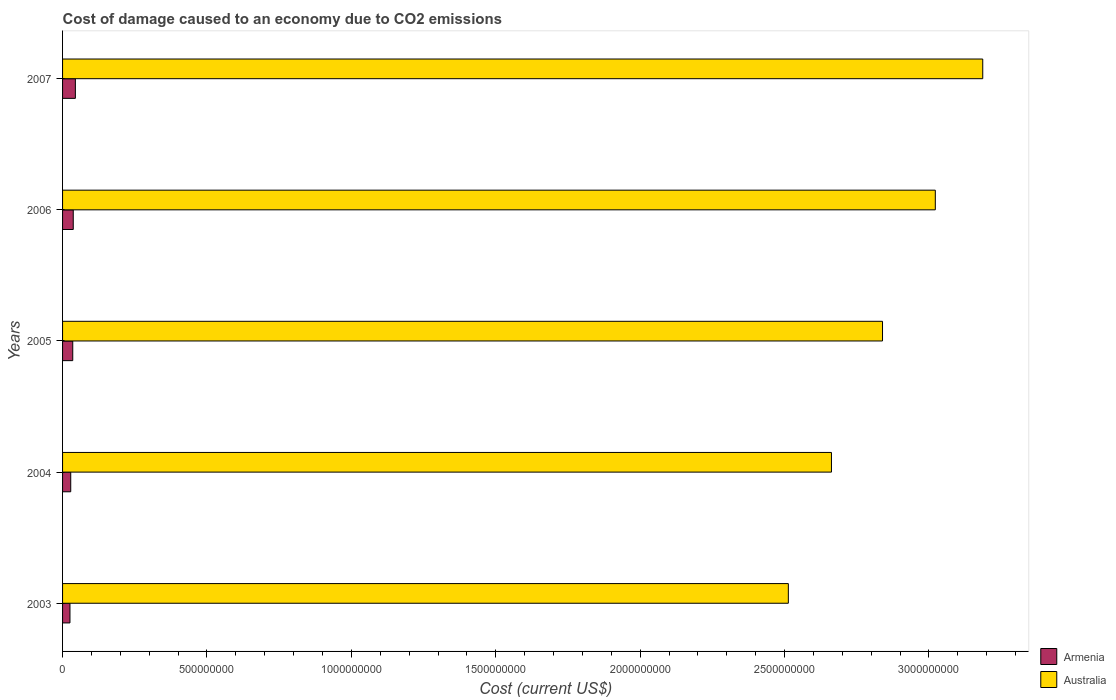Are the number of bars per tick equal to the number of legend labels?
Provide a succinct answer. Yes. Are the number of bars on each tick of the Y-axis equal?
Your response must be concise. Yes. How many bars are there on the 1st tick from the bottom?
Offer a terse response. 2. What is the cost of damage caused due to CO2 emissisons in Australia in 2007?
Offer a terse response. 3.19e+09. Across all years, what is the maximum cost of damage caused due to CO2 emissisons in Australia?
Provide a short and direct response. 3.19e+09. Across all years, what is the minimum cost of damage caused due to CO2 emissisons in Australia?
Give a very brief answer. 2.51e+09. In which year was the cost of damage caused due to CO2 emissisons in Australia maximum?
Offer a terse response. 2007. In which year was the cost of damage caused due to CO2 emissisons in Armenia minimum?
Your answer should be compact. 2003. What is the total cost of damage caused due to CO2 emissisons in Armenia in the graph?
Offer a very short reply. 1.71e+08. What is the difference between the cost of damage caused due to CO2 emissisons in Armenia in 2005 and that in 2006?
Provide a short and direct response. -1.71e+06. What is the difference between the cost of damage caused due to CO2 emissisons in Australia in 2006 and the cost of damage caused due to CO2 emissisons in Armenia in 2003?
Your answer should be very brief. 3.00e+09. What is the average cost of damage caused due to CO2 emissisons in Australia per year?
Offer a very short reply. 2.84e+09. In the year 2006, what is the difference between the cost of damage caused due to CO2 emissisons in Armenia and cost of damage caused due to CO2 emissisons in Australia?
Provide a succinct answer. -2.98e+09. What is the ratio of the cost of damage caused due to CO2 emissisons in Armenia in 2006 to that in 2007?
Provide a short and direct response. 0.83. Is the cost of damage caused due to CO2 emissisons in Australia in 2003 less than that in 2004?
Your response must be concise. Yes. Is the difference between the cost of damage caused due to CO2 emissisons in Armenia in 2003 and 2004 greater than the difference between the cost of damage caused due to CO2 emissisons in Australia in 2003 and 2004?
Provide a succinct answer. Yes. What is the difference between the highest and the second highest cost of damage caused due to CO2 emissisons in Australia?
Give a very brief answer. 1.64e+08. What is the difference between the highest and the lowest cost of damage caused due to CO2 emissisons in Australia?
Give a very brief answer. 6.73e+08. What does the 2nd bar from the top in 2006 represents?
Your response must be concise. Armenia. What does the 2nd bar from the bottom in 2004 represents?
Ensure brevity in your answer.  Australia. What is the difference between two consecutive major ticks on the X-axis?
Make the answer very short. 5.00e+08. Are the values on the major ticks of X-axis written in scientific E-notation?
Give a very brief answer. No. Does the graph contain any zero values?
Offer a terse response. No. Where does the legend appear in the graph?
Give a very brief answer. Bottom right. How many legend labels are there?
Offer a very short reply. 2. What is the title of the graph?
Give a very brief answer. Cost of damage caused to an economy due to CO2 emissions. What is the label or title of the X-axis?
Your response must be concise. Cost (current US$). What is the Cost (current US$) of Armenia in 2003?
Offer a terse response. 2.56e+07. What is the Cost (current US$) in Australia in 2003?
Make the answer very short. 2.51e+09. What is the Cost (current US$) of Armenia in 2004?
Your answer should be very brief. 2.83e+07. What is the Cost (current US$) of Australia in 2004?
Provide a succinct answer. 2.66e+09. What is the Cost (current US$) of Armenia in 2005?
Offer a very short reply. 3.53e+07. What is the Cost (current US$) in Australia in 2005?
Offer a very short reply. 2.84e+09. What is the Cost (current US$) in Armenia in 2006?
Give a very brief answer. 3.70e+07. What is the Cost (current US$) of Australia in 2006?
Your answer should be compact. 3.02e+09. What is the Cost (current US$) in Armenia in 2007?
Provide a short and direct response. 4.44e+07. What is the Cost (current US$) in Australia in 2007?
Your response must be concise. 3.19e+09. Across all years, what is the maximum Cost (current US$) in Armenia?
Provide a short and direct response. 4.44e+07. Across all years, what is the maximum Cost (current US$) in Australia?
Offer a terse response. 3.19e+09. Across all years, what is the minimum Cost (current US$) of Armenia?
Keep it short and to the point. 2.56e+07. Across all years, what is the minimum Cost (current US$) in Australia?
Your answer should be very brief. 2.51e+09. What is the total Cost (current US$) of Armenia in the graph?
Keep it short and to the point. 1.71e+08. What is the total Cost (current US$) of Australia in the graph?
Make the answer very short. 1.42e+1. What is the difference between the Cost (current US$) in Armenia in 2003 and that in 2004?
Offer a terse response. -2.69e+06. What is the difference between the Cost (current US$) of Australia in 2003 and that in 2004?
Give a very brief answer. -1.49e+08. What is the difference between the Cost (current US$) in Armenia in 2003 and that in 2005?
Provide a succinct answer. -9.66e+06. What is the difference between the Cost (current US$) in Australia in 2003 and that in 2005?
Your answer should be compact. -3.26e+08. What is the difference between the Cost (current US$) in Armenia in 2003 and that in 2006?
Your answer should be compact. -1.14e+07. What is the difference between the Cost (current US$) in Australia in 2003 and that in 2006?
Provide a succinct answer. -5.09e+08. What is the difference between the Cost (current US$) of Armenia in 2003 and that in 2007?
Your response must be concise. -1.87e+07. What is the difference between the Cost (current US$) of Australia in 2003 and that in 2007?
Your answer should be compact. -6.73e+08. What is the difference between the Cost (current US$) in Armenia in 2004 and that in 2005?
Offer a terse response. -6.97e+06. What is the difference between the Cost (current US$) in Australia in 2004 and that in 2005?
Provide a succinct answer. -1.77e+08. What is the difference between the Cost (current US$) in Armenia in 2004 and that in 2006?
Your answer should be compact. -8.68e+06. What is the difference between the Cost (current US$) of Australia in 2004 and that in 2006?
Ensure brevity in your answer.  -3.60e+08. What is the difference between the Cost (current US$) of Armenia in 2004 and that in 2007?
Provide a short and direct response. -1.60e+07. What is the difference between the Cost (current US$) of Australia in 2004 and that in 2007?
Give a very brief answer. -5.24e+08. What is the difference between the Cost (current US$) in Armenia in 2005 and that in 2006?
Give a very brief answer. -1.71e+06. What is the difference between the Cost (current US$) of Australia in 2005 and that in 2006?
Make the answer very short. -1.83e+08. What is the difference between the Cost (current US$) of Armenia in 2005 and that in 2007?
Provide a short and direct response. -9.07e+06. What is the difference between the Cost (current US$) of Australia in 2005 and that in 2007?
Your response must be concise. -3.47e+08. What is the difference between the Cost (current US$) of Armenia in 2006 and that in 2007?
Make the answer very short. -7.36e+06. What is the difference between the Cost (current US$) in Australia in 2006 and that in 2007?
Your response must be concise. -1.64e+08. What is the difference between the Cost (current US$) in Armenia in 2003 and the Cost (current US$) in Australia in 2004?
Provide a short and direct response. -2.64e+09. What is the difference between the Cost (current US$) in Armenia in 2003 and the Cost (current US$) in Australia in 2005?
Provide a succinct answer. -2.81e+09. What is the difference between the Cost (current US$) in Armenia in 2003 and the Cost (current US$) in Australia in 2006?
Provide a short and direct response. -3.00e+09. What is the difference between the Cost (current US$) of Armenia in 2003 and the Cost (current US$) of Australia in 2007?
Offer a terse response. -3.16e+09. What is the difference between the Cost (current US$) of Armenia in 2004 and the Cost (current US$) of Australia in 2005?
Provide a short and direct response. -2.81e+09. What is the difference between the Cost (current US$) in Armenia in 2004 and the Cost (current US$) in Australia in 2006?
Offer a terse response. -2.99e+09. What is the difference between the Cost (current US$) in Armenia in 2004 and the Cost (current US$) in Australia in 2007?
Provide a succinct answer. -3.16e+09. What is the difference between the Cost (current US$) in Armenia in 2005 and the Cost (current US$) in Australia in 2006?
Ensure brevity in your answer.  -2.99e+09. What is the difference between the Cost (current US$) of Armenia in 2005 and the Cost (current US$) of Australia in 2007?
Your answer should be very brief. -3.15e+09. What is the difference between the Cost (current US$) of Armenia in 2006 and the Cost (current US$) of Australia in 2007?
Your response must be concise. -3.15e+09. What is the average Cost (current US$) in Armenia per year?
Offer a very short reply. 3.41e+07. What is the average Cost (current US$) in Australia per year?
Provide a short and direct response. 2.84e+09. In the year 2003, what is the difference between the Cost (current US$) of Armenia and Cost (current US$) of Australia?
Provide a succinct answer. -2.49e+09. In the year 2004, what is the difference between the Cost (current US$) in Armenia and Cost (current US$) in Australia?
Offer a terse response. -2.63e+09. In the year 2005, what is the difference between the Cost (current US$) in Armenia and Cost (current US$) in Australia?
Provide a short and direct response. -2.80e+09. In the year 2006, what is the difference between the Cost (current US$) of Armenia and Cost (current US$) of Australia?
Your answer should be compact. -2.98e+09. In the year 2007, what is the difference between the Cost (current US$) in Armenia and Cost (current US$) in Australia?
Offer a terse response. -3.14e+09. What is the ratio of the Cost (current US$) in Armenia in 2003 to that in 2004?
Offer a terse response. 0.9. What is the ratio of the Cost (current US$) of Australia in 2003 to that in 2004?
Your answer should be compact. 0.94. What is the ratio of the Cost (current US$) of Armenia in 2003 to that in 2005?
Your answer should be compact. 0.73. What is the ratio of the Cost (current US$) in Australia in 2003 to that in 2005?
Offer a terse response. 0.89. What is the ratio of the Cost (current US$) in Armenia in 2003 to that in 2006?
Provide a succinct answer. 0.69. What is the ratio of the Cost (current US$) in Australia in 2003 to that in 2006?
Your response must be concise. 0.83. What is the ratio of the Cost (current US$) of Armenia in 2003 to that in 2007?
Offer a terse response. 0.58. What is the ratio of the Cost (current US$) in Australia in 2003 to that in 2007?
Make the answer very short. 0.79. What is the ratio of the Cost (current US$) in Armenia in 2004 to that in 2005?
Your answer should be compact. 0.8. What is the ratio of the Cost (current US$) of Australia in 2004 to that in 2005?
Offer a very short reply. 0.94. What is the ratio of the Cost (current US$) in Armenia in 2004 to that in 2006?
Offer a very short reply. 0.77. What is the ratio of the Cost (current US$) in Australia in 2004 to that in 2006?
Make the answer very short. 0.88. What is the ratio of the Cost (current US$) in Armenia in 2004 to that in 2007?
Your answer should be very brief. 0.64. What is the ratio of the Cost (current US$) in Australia in 2004 to that in 2007?
Provide a succinct answer. 0.84. What is the ratio of the Cost (current US$) of Armenia in 2005 to that in 2006?
Make the answer very short. 0.95. What is the ratio of the Cost (current US$) of Australia in 2005 to that in 2006?
Offer a terse response. 0.94. What is the ratio of the Cost (current US$) of Armenia in 2005 to that in 2007?
Provide a short and direct response. 0.8. What is the ratio of the Cost (current US$) in Australia in 2005 to that in 2007?
Ensure brevity in your answer.  0.89. What is the ratio of the Cost (current US$) in Armenia in 2006 to that in 2007?
Make the answer very short. 0.83. What is the ratio of the Cost (current US$) of Australia in 2006 to that in 2007?
Give a very brief answer. 0.95. What is the difference between the highest and the second highest Cost (current US$) in Armenia?
Keep it short and to the point. 7.36e+06. What is the difference between the highest and the second highest Cost (current US$) of Australia?
Your response must be concise. 1.64e+08. What is the difference between the highest and the lowest Cost (current US$) of Armenia?
Provide a succinct answer. 1.87e+07. What is the difference between the highest and the lowest Cost (current US$) of Australia?
Give a very brief answer. 6.73e+08. 